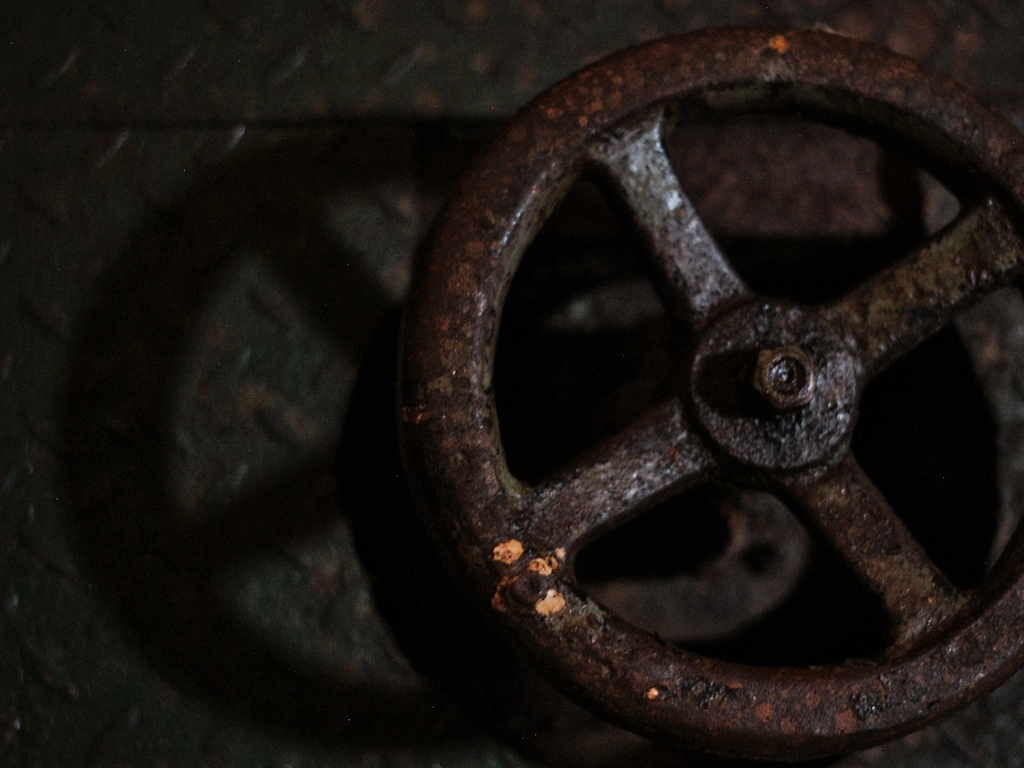What does the texture of this object indicate about its environment? The rust and wear on the valve wheel suggest it was exposed to moisture and perhaps corrosive elements. It likely existed in a harsh environment, such as a factory or outdoor setting where metal objects are prone to oxidization over time. 